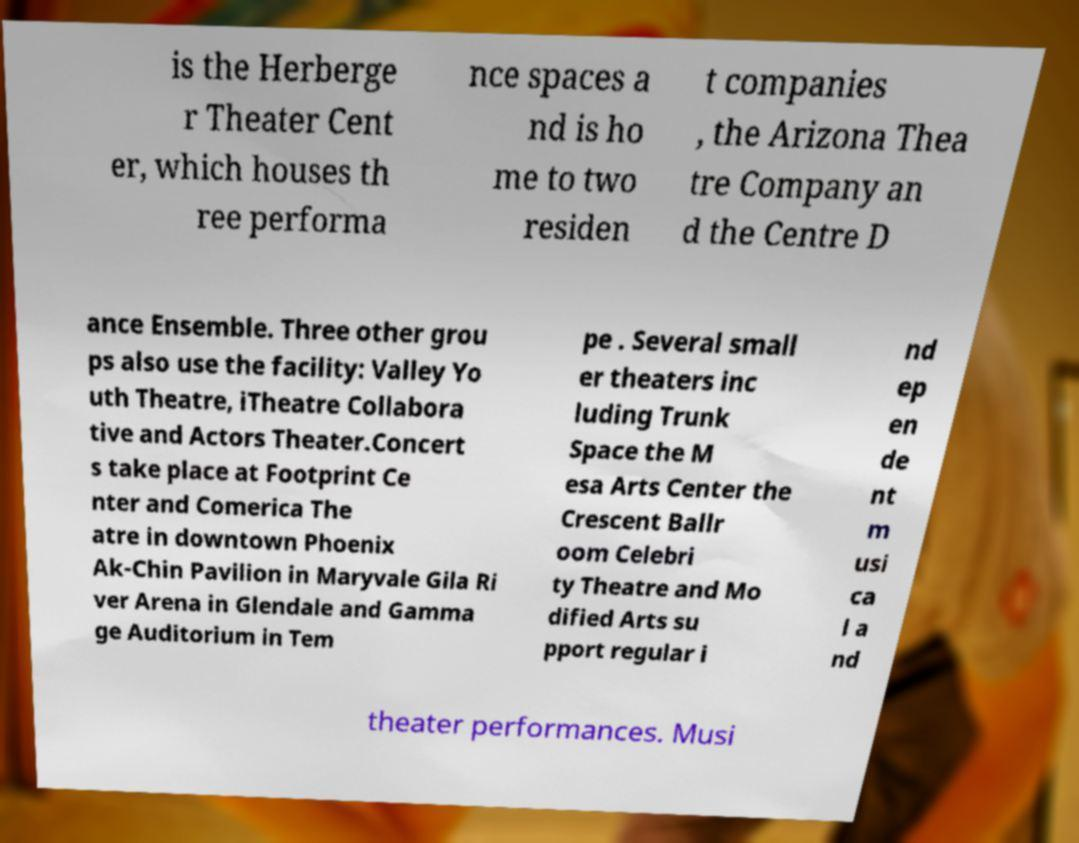Could you assist in decoding the text presented in this image and type it out clearly? is the Herberge r Theater Cent er, which houses th ree performa nce spaces a nd is ho me to two residen t companies , the Arizona Thea tre Company an d the Centre D ance Ensemble. Three other grou ps also use the facility: Valley Yo uth Theatre, iTheatre Collabora tive and Actors Theater.Concert s take place at Footprint Ce nter and Comerica The atre in downtown Phoenix Ak-Chin Pavilion in Maryvale Gila Ri ver Arena in Glendale and Gamma ge Auditorium in Tem pe . Several small er theaters inc luding Trunk Space the M esa Arts Center the Crescent Ballr oom Celebri ty Theatre and Mo dified Arts su pport regular i nd ep en de nt m usi ca l a nd theater performances. Musi 